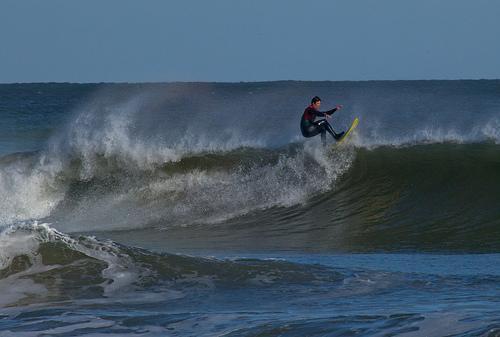How many surfers in picture?
Give a very brief answer. 1. 